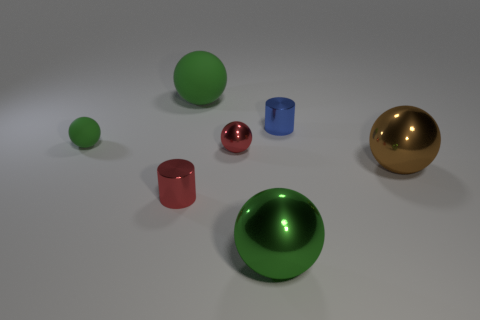Subtract all green balls. How many were subtracted if there are1green balls left? 2 Subtract all cyan cubes. How many green balls are left? 3 Subtract all big matte balls. How many balls are left? 4 Subtract all red balls. How many balls are left? 4 Subtract all purple balls. Subtract all blue cylinders. How many balls are left? 5 Add 2 green shiny spheres. How many objects exist? 9 Subtract all cylinders. How many objects are left? 5 Subtract all yellow objects. Subtract all big green spheres. How many objects are left? 5 Add 6 red things. How many red things are left? 8 Add 7 big brown metallic spheres. How many big brown metallic spheres exist? 8 